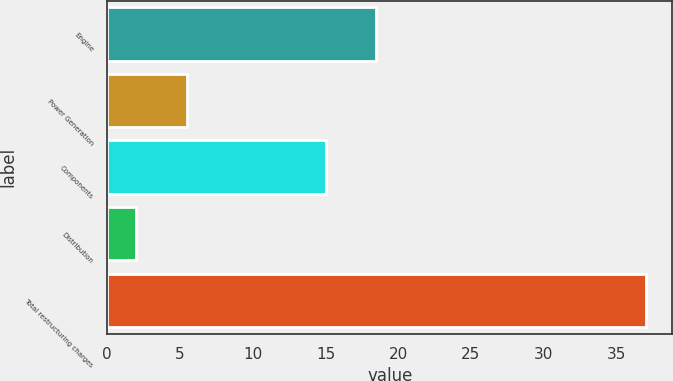<chart> <loc_0><loc_0><loc_500><loc_500><bar_chart><fcel>Engine<fcel>Power Generation<fcel>Components<fcel>Distribution<fcel>Total restructuring charges<nl><fcel>18.5<fcel>5.5<fcel>15<fcel>2<fcel>37<nl></chart> 